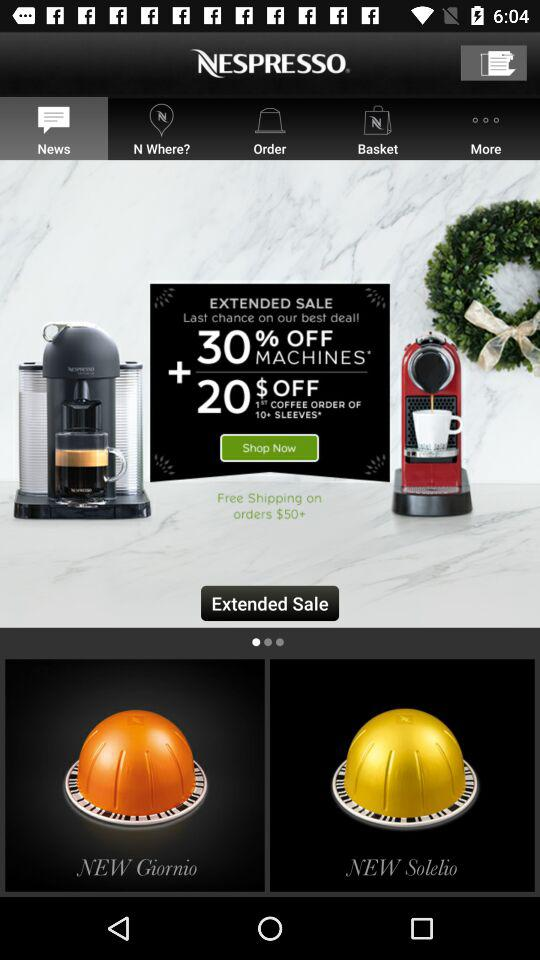What tab am I using? You are using the "News" tab. 